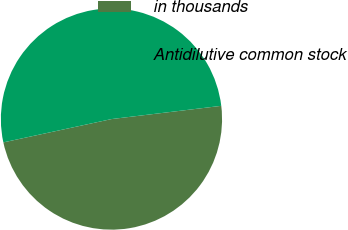<chart> <loc_0><loc_0><loc_500><loc_500><pie_chart><fcel>in thousands<fcel>Antidilutive common stock<nl><fcel>48.53%<fcel>51.47%<nl></chart> 